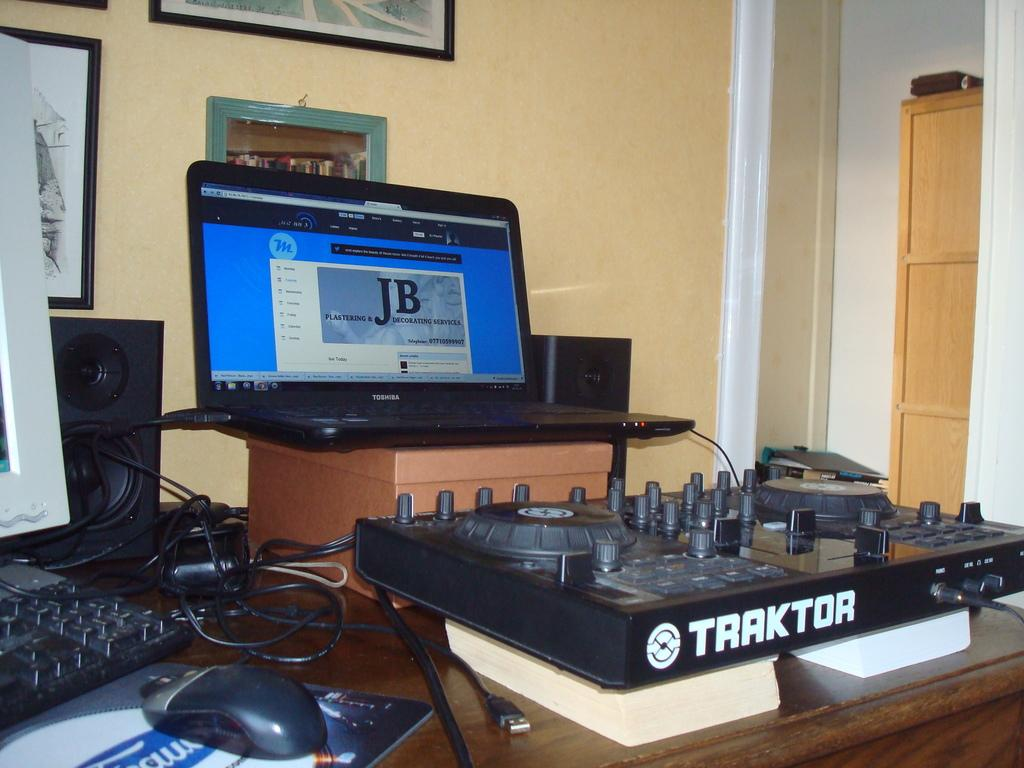What electronic device is visible in the image? There is a laptop in the image. What objects are used for audio output in the image? There are speakers in the image. What device is used for controlling the laptop cursor? There is a mouse in the image. What device is used for amplifying sound in the image? There is an amplifier in the image. On what surface are these objects placed? These objects are on a wooden table. What type of decoration is present on the wall behind the table? There are photos on the wall behind the table. What piece of furniture is located on the right side of the image? There is a cupboard on the right side of the image. What type of twig can be seen growing from the laptop in the image? There is no twig growing from the laptop in the image. What is the name of the downtown area visible in the image? There is no downtown area visible in the image. 